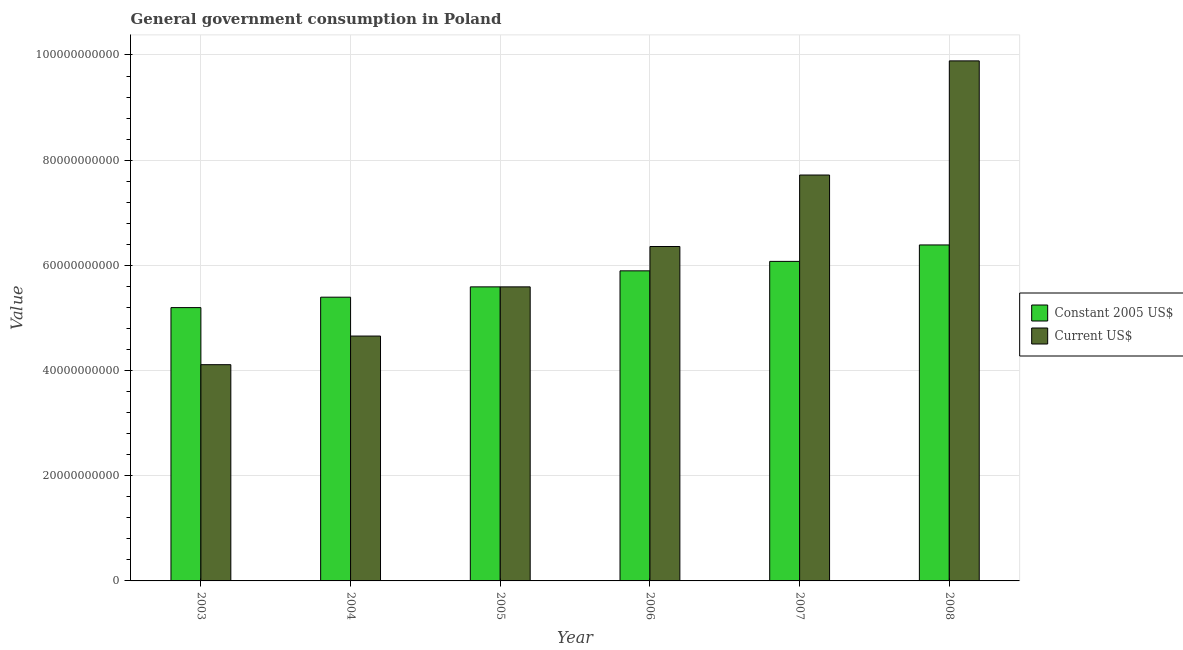How many different coloured bars are there?
Your answer should be compact. 2. How many groups of bars are there?
Your response must be concise. 6. Are the number of bars on each tick of the X-axis equal?
Offer a terse response. Yes. How many bars are there on the 2nd tick from the left?
Your answer should be very brief. 2. What is the value consumed in constant 2005 us$ in 2007?
Your answer should be very brief. 6.08e+1. Across all years, what is the maximum value consumed in current us$?
Offer a terse response. 9.89e+1. Across all years, what is the minimum value consumed in current us$?
Keep it short and to the point. 4.11e+1. What is the total value consumed in current us$ in the graph?
Ensure brevity in your answer.  3.83e+11. What is the difference between the value consumed in current us$ in 2003 and that in 2005?
Keep it short and to the point. -1.48e+1. What is the difference between the value consumed in constant 2005 us$ in 2003 and the value consumed in current us$ in 2004?
Provide a succinct answer. -1.98e+09. What is the average value consumed in constant 2005 us$ per year?
Your answer should be compact. 5.76e+1. What is the ratio of the value consumed in current us$ in 2004 to that in 2005?
Your answer should be very brief. 0.83. Is the value consumed in current us$ in 2006 less than that in 2007?
Provide a short and direct response. Yes. What is the difference between the highest and the second highest value consumed in current us$?
Keep it short and to the point. 2.17e+1. What is the difference between the highest and the lowest value consumed in current us$?
Your response must be concise. 5.78e+1. What does the 2nd bar from the left in 2003 represents?
Provide a short and direct response. Current US$. What does the 1st bar from the right in 2004 represents?
Provide a short and direct response. Current US$. How many bars are there?
Offer a very short reply. 12. How many years are there in the graph?
Provide a short and direct response. 6. Are the values on the major ticks of Y-axis written in scientific E-notation?
Provide a succinct answer. No. Does the graph contain any zero values?
Ensure brevity in your answer.  No. How are the legend labels stacked?
Your answer should be very brief. Vertical. What is the title of the graph?
Your answer should be compact. General government consumption in Poland. Does "Electricity and heat production" appear as one of the legend labels in the graph?
Your answer should be compact. No. What is the label or title of the Y-axis?
Offer a very short reply. Value. What is the Value of Constant 2005 US$ in 2003?
Make the answer very short. 5.20e+1. What is the Value in Current US$ in 2003?
Your answer should be compact. 4.11e+1. What is the Value of Constant 2005 US$ in 2004?
Offer a terse response. 5.39e+1. What is the Value of Current US$ in 2004?
Provide a succinct answer. 4.66e+1. What is the Value of Constant 2005 US$ in 2005?
Provide a succinct answer. 5.59e+1. What is the Value of Current US$ in 2005?
Provide a short and direct response. 5.59e+1. What is the Value in Constant 2005 US$ in 2006?
Provide a succinct answer. 5.90e+1. What is the Value of Current US$ in 2006?
Provide a succinct answer. 6.36e+1. What is the Value of Constant 2005 US$ in 2007?
Offer a terse response. 6.08e+1. What is the Value in Current US$ in 2007?
Offer a terse response. 7.72e+1. What is the Value in Constant 2005 US$ in 2008?
Provide a short and direct response. 6.39e+1. What is the Value of Current US$ in 2008?
Provide a short and direct response. 9.89e+1. Across all years, what is the maximum Value of Constant 2005 US$?
Your answer should be very brief. 6.39e+1. Across all years, what is the maximum Value of Current US$?
Offer a terse response. 9.89e+1. Across all years, what is the minimum Value of Constant 2005 US$?
Give a very brief answer. 5.20e+1. Across all years, what is the minimum Value in Current US$?
Give a very brief answer. 4.11e+1. What is the total Value of Constant 2005 US$ in the graph?
Make the answer very short. 3.45e+11. What is the total Value in Current US$ in the graph?
Make the answer very short. 3.83e+11. What is the difference between the Value in Constant 2005 US$ in 2003 and that in 2004?
Give a very brief answer. -1.98e+09. What is the difference between the Value of Current US$ in 2003 and that in 2004?
Keep it short and to the point. -5.44e+09. What is the difference between the Value in Constant 2005 US$ in 2003 and that in 2005?
Your answer should be very brief. -3.94e+09. What is the difference between the Value in Current US$ in 2003 and that in 2005?
Make the answer very short. -1.48e+1. What is the difference between the Value of Constant 2005 US$ in 2003 and that in 2006?
Keep it short and to the point. -6.99e+09. What is the difference between the Value of Current US$ in 2003 and that in 2006?
Make the answer very short. -2.25e+1. What is the difference between the Value in Constant 2005 US$ in 2003 and that in 2007?
Make the answer very short. -8.79e+09. What is the difference between the Value in Current US$ in 2003 and that in 2007?
Offer a terse response. -3.61e+1. What is the difference between the Value in Constant 2005 US$ in 2003 and that in 2008?
Provide a succinct answer. -1.19e+1. What is the difference between the Value of Current US$ in 2003 and that in 2008?
Keep it short and to the point. -5.78e+1. What is the difference between the Value in Constant 2005 US$ in 2004 and that in 2005?
Your answer should be compact. -1.96e+09. What is the difference between the Value in Current US$ in 2004 and that in 2005?
Offer a terse response. -9.35e+09. What is the difference between the Value of Constant 2005 US$ in 2004 and that in 2006?
Offer a very short reply. -5.01e+09. What is the difference between the Value of Current US$ in 2004 and that in 2006?
Your response must be concise. -1.70e+1. What is the difference between the Value in Constant 2005 US$ in 2004 and that in 2007?
Offer a very short reply. -6.81e+09. What is the difference between the Value of Current US$ in 2004 and that in 2007?
Ensure brevity in your answer.  -3.06e+1. What is the difference between the Value of Constant 2005 US$ in 2004 and that in 2008?
Keep it short and to the point. -9.93e+09. What is the difference between the Value of Current US$ in 2004 and that in 2008?
Your response must be concise. -5.23e+1. What is the difference between the Value of Constant 2005 US$ in 2005 and that in 2006?
Your answer should be compact. -3.05e+09. What is the difference between the Value in Current US$ in 2005 and that in 2006?
Keep it short and to the point. -7.67e+09. What is the difference between the Value of Constant 2005 US$ in 2005 and that in 2007?
Keep it short and to the point. -4.85e+09. What is the difference between the Value of Current US$ in 2005 and that in 2007?
Keep it short and to the point. -2.13e+1. What is the difference between the Value in Constant 2005 US$ in 2005 and that in 2008?
Your answer should be compact. -7.97e+09. What is the difference between the Value of Current US$ in 2005 and that in 2008?
Your answer should be very brief. -4.30e+1. What is the difference between the Value in Constant 2005 US$ in 2006 and that in 2007?
Ensure brevity in your answer.  -1.80e+09. What is the difference between the Value in Current US$ in 2006 and that in 2007?
Provide a short and direct response. -1.36e+1. What is the difference between the Value of Constant 2005 US$ in 2006 and that in 2008?
Your answer should be very brief. -4.92e+09. What is the difference between the Value of Current US$ in 2006 and that in 2008?
Your response must be concise. -3.53e+1. What is the difference between the Value in Constant 2005 US$ in 2007 and that in 2008?
Provide a succinct answer. -3.13e+09. What is the difference between the Value of Current US$ in 2007 and that in 2008?
Offer a terse response. -2.17e+1. What is the difference between the Value in Constant 2005 US$ in 2003 and the Value in Current US$ in 2004?
Your answer should be compact. 5.41e+09. What is the difference between the Value of Constant 2005 US$ in 2003 and the Value of Current US$ in 2005?
Ensure brevity in your answer.  -3.94e+09. What is the difference between the Value of Constant 2005 US$ in 2003 and the Value of Current US$ in 2006?
Give a very brief answer. -1.16e+1. What is the difference between the Value in Constant 2005 US$ in 2003 and the Value in Current US$ in 2007?
Offer a terse response. -2.52e+1. What is the difference between the Value of Constant 2005 US$ in 2003 and the Value of Current US$ in 2008?
Your answer should be compact. -4.69e+1. What is the difference between the Value in Constant 2005 US$ in 2004 and the Value in Current US$ in 2005?
Provide a short and direct response. -1.96e+09. What is the difference between the Value in Constant 2005 US$ in 2004 and the Value in Current US$ in 2006?
Your response must be concise. -9.63e+09. What is the difference between the Value in Constant 2005 US$ in 2004 and the Value in Current US$ in 2007?
Your answer should be compact. -2.32e+1. What is the difference between the Value in Constant 2005 US$ in 2004 and the Value in Current US$ in 2008?
Provide a succinct answer. -4.49e+1. What is the difference between the Value in Constant 2005 US$ in 2005 and the Value in Current US$ in 2006?
Your answer should be very brief. -7.67e+09. What is the difference between the Value in Constant 2005 US$ in 2005 and the Value in Current US$ in 2007?
Ensure brevity in your answer.  -2.13e+1. What is the difference between the Value in Constant 2005 US$ in 2005 and the Value in Current US$ in 2008?
Offer a very short reply. -4.30e+1. What is the difference between the Value in Constant 2005 US$ in 2006 and the Value in Current US$ in 2007?
Keep it short and to the point. -1.82e+1. What is the difference between the Value in Constant 2005 US$ in 2006 and the Value in Current US$ in 2008?
Keep it short and to the point. -3.99e+1. What is the difference between the Value in Constant 2005 US$ in 2007 and the Value in Current US$ in 2008?
Offer a very short reply. -3.81e+1. What is the average Value in Constant 2005 US$ per year?
Offer a terse response. 5.76e+1. What is the average Value of Current US$ per year?
Your response must be concise. 6.39e+1. In the year 2003, what is the difference between the Value of Constant 2005 US$ and Value of Current US$?
Your answer should be compact. 1.09e+1. In the year 2004, what is the difference between the Value of Constant 2005 US$ and Value of Current US$?
Give a very brief answer. 7.39e+09. In the year 2006, what is the difference between the Value of Constant 2005 US$ and Value of Current US$?
Provide a succinct answer. -4.63e+09. In the year 2007, what is the difference between the Value in Constant 2005 US$ and Value in Current US$?
Offer a very short reply. -1.64e+1. In the year 2008, what is the difference between the Value in Constant 2005 US$ and Value in Current US$?
Your response must be concise. -3.50e+1. What is the ratio of the Value of Constant 2005 US$ in 2003 to that in 2004?
Provide a short and direct response. 0.96. What is the ratio of the Value of Current US$ in 2003 to that in 2004?
Your answer should be very brief. 0.88. What is the ratio of the Value of Constant 2005 US$ in 2003 to that in 2005?
Offer a terse response. 0.93. What is the ratio of the Value in Current US$ in 2003 to that in 2005?
Keep it short and to the point. 0.74. What is the ratio of the Value in Constant 2005 US$ in 2003 to that in 2006?
Make the answer very short. 0.88. What is the ratio of the Value of Current US$ in 2003 to that in 2006?
Your answer should be compact. 0.65. What is the ratio of the Value of Constant 2005 US$ in 2003 to that in 2007?
Provide a short and direct response. 0.86. What is the ratio of the Value in Current US$ in 2003 to that in 2007?
Your answer should be compact. 0.53. What is the ratio of the Value of Constant 2005 US$ in 2003 to that in 2008?
Give a very brief answer. 0.81. What is the ratio of the Value in Current US$ in 2003 to that in 2008?
Provide a short and direct response. 0.42. What is the ratio of the Value in Constant 2005 US$ in 2004 to that in 2005?
Offer a very short reply. 0.96. What is the ratio of the Value of Current US$ in 2004 to that in 2005?
Your response must be concise. 0.83. What is the ratio of the Value of Constant 2005 US$ in 2004 to that in 2006?
Your response must be concise. 0.92. What is the ratio of the Value in Current US$ in 2004 to that in 2006?
Keep it short and to the point. 0.73. What is the ratio of the Value in Constant 2005 US$ in 2004 to that in 2007?
Your answer should be very brief. 0.89. What is the ratio of the Value in Current US$ in 2004 to that in 2007?
Give a very brief answer. 0.6. What is the ratio of the Value in Constant 2005 US$ in 2004 to that in 2008?
Offer a terse response. 0.84. What is the ratio of the Value of Current US$ in 2004 to that in 2008?
Keep it short and to the point. 0.47. What is the ratio of the Value in Constant 2005 US$ in 2005 to that in 2006?
Your answer should be very brief. 0.95. What is the ratio of the Value in Current US$ in 2005 to that in 2006?
Give a very brief answer. 0.88. What is the ratio of the Value in Constant 2005 US$ in 2005 to that in 2007?
Your response must be concise. 0.92. What is the ratio of the Value in Current US$ in 2005 to that in 2007?
Your response must be concise. 0.72. What is the ratio of the Value of Constant 2005 US$ in 2005 to that in 2008?
Make the answer very short. 0.88. What is the ratio of the Value of Current US$ in 2005 to that in 2008?
Offer a terse response. 0.57. What is the ratio of the Value of Constant 2005 US$ in 2006 to that in 2007?
Your answer should be very brief. 0.97. What is the ratio of the Value in Current US$ in 2006 to that in 2007?
Your answer should be compact. 0.82. What is the ratio of the Value of Constant 2005 US$ in 2006 to that in 2008?
Offer a terse response. 0.92. What is the ratio of the Value of Current US$ in 2006 to that in 2008?
Provide a short and direct response. 0.64. What is the ratio of the Value in Constant 2005 US$ in 2007 to that in 2008?
Offer a terse response. 0.95. What is the ratio of the Value of Current US$ in 2007 to that in 2008?
Your answer should be compact. 0.78. What is the difference between the highest and the second highest Value of Constant 2005 US$?
Make the answer very short. 3.13e+09. What is the difference between the highest and the second highest Value in Current US$?
Make the answer very short. 2.17e+1. What is the difference between the highest and the lowest Value in Constant 2005 US$?
Your answer should be very brief. 1.19e+1. What is the difference between the highest and the lowest Value of Current US$?
Offer a very short reply. 5.78e+1. 